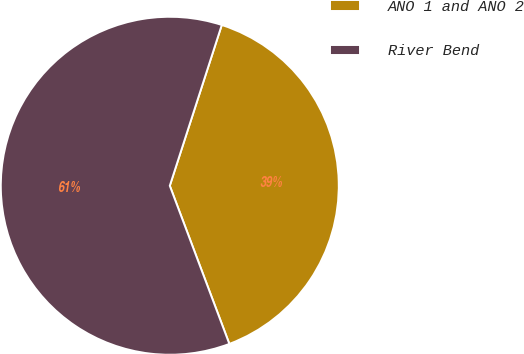Convert chart to OTSL. <chart><loc_0><loc_0><loc_500><loc_500><pie_chart><fcel>ANO 1 and ANO 2<fcel>River Bend<nl><fcel>39.29%<fcel>60.71%<nl></chart> 